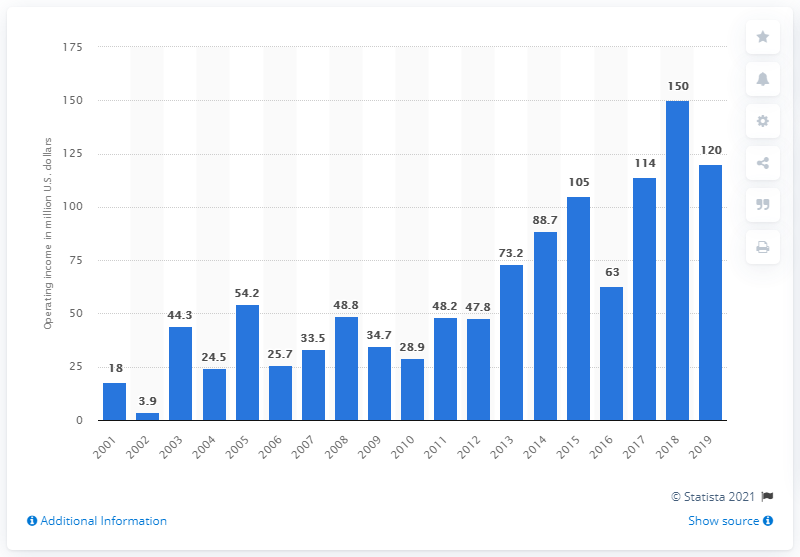Outline some significant characteristics in this image. The operating income of the Philadelphia Eagles during the 2019 season was $120 million. 